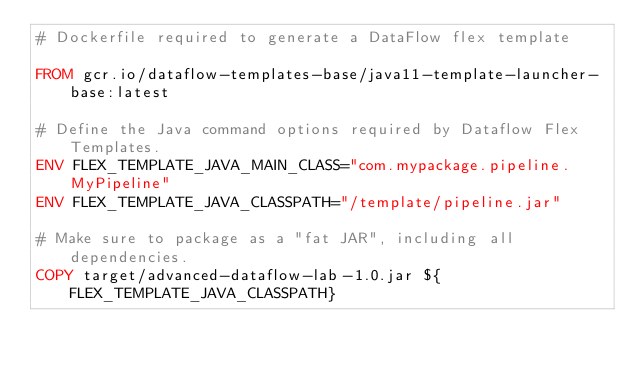Convert code to text. <code><loc_0><loc_0><loc_500><loc_500><_Dockerfile_># Dockerfile required to generate a DataFlow flex template

FROM gcr.io/dataflow-templates-base/java11-template-launcher-base:latest

# Define the Java command options required by Dataflow Flex Templates.
ENV FLEX_TEMPLATE_JAVA_MAIN_CLASS="com.mypackage.pipeline.MyPipeline"
ENV FLEX_TEMPLATE_JAVA_CLASSPATH="/template/pipeline.jar"

# Make sure to package as a "fat JAR", including all dependencies.
COPY target/advanced-dataflow-lab-1.0.jar ${FLEX_TEMPLATE_JAVA_CLASSPATH}
</code> 